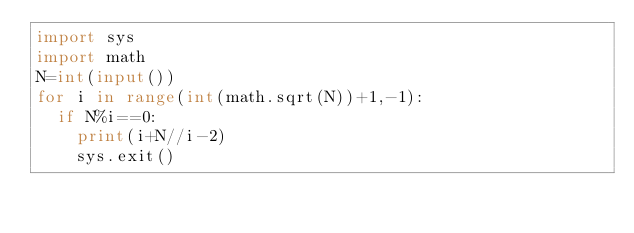Convert code to text. <code><loc_0><loc_0><loc_500><loc_500><_Python_>import sys
import math
N=int(input())
for i in range(int(math.sqrt(N))+1,-1):
  if N%i==0:
    print(i+N//i-2)
    sys.exit()
               </code> 